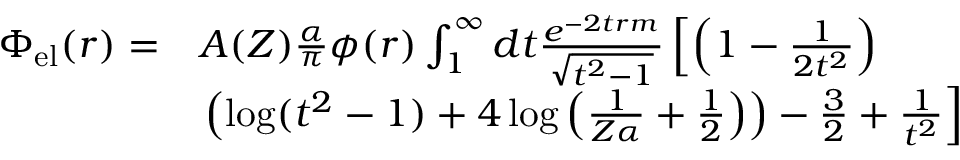<formula> <loc_0><loc_0><loc_500><loc_500>\begin{array} { r l } { \Phi _ { e l } ( r ) = } & { A ( Z ) \frac { \alpha } { \pi } \phi ( r ) \int _ { 1 } ^ { \infty } d t \frac { e ^ { - 2 t r m } } { \sqrt { t ^ { 2 } - 1 } } \left [ \left ( 1 - \frac { 1 } { 2 t ^ { 2 } } \right ) } \\ & { \left ( \log ( t ^ { 2 } - 1 ) + 4 \log \left ( \frac { 1 } { Z \alpha } + \frac { 1 } { 2 } \right ) \right ) - \frac { 3 } { 2 } + \frac { 1 } { t ^ { 2 } } \right ] } \end{array}</formula> 